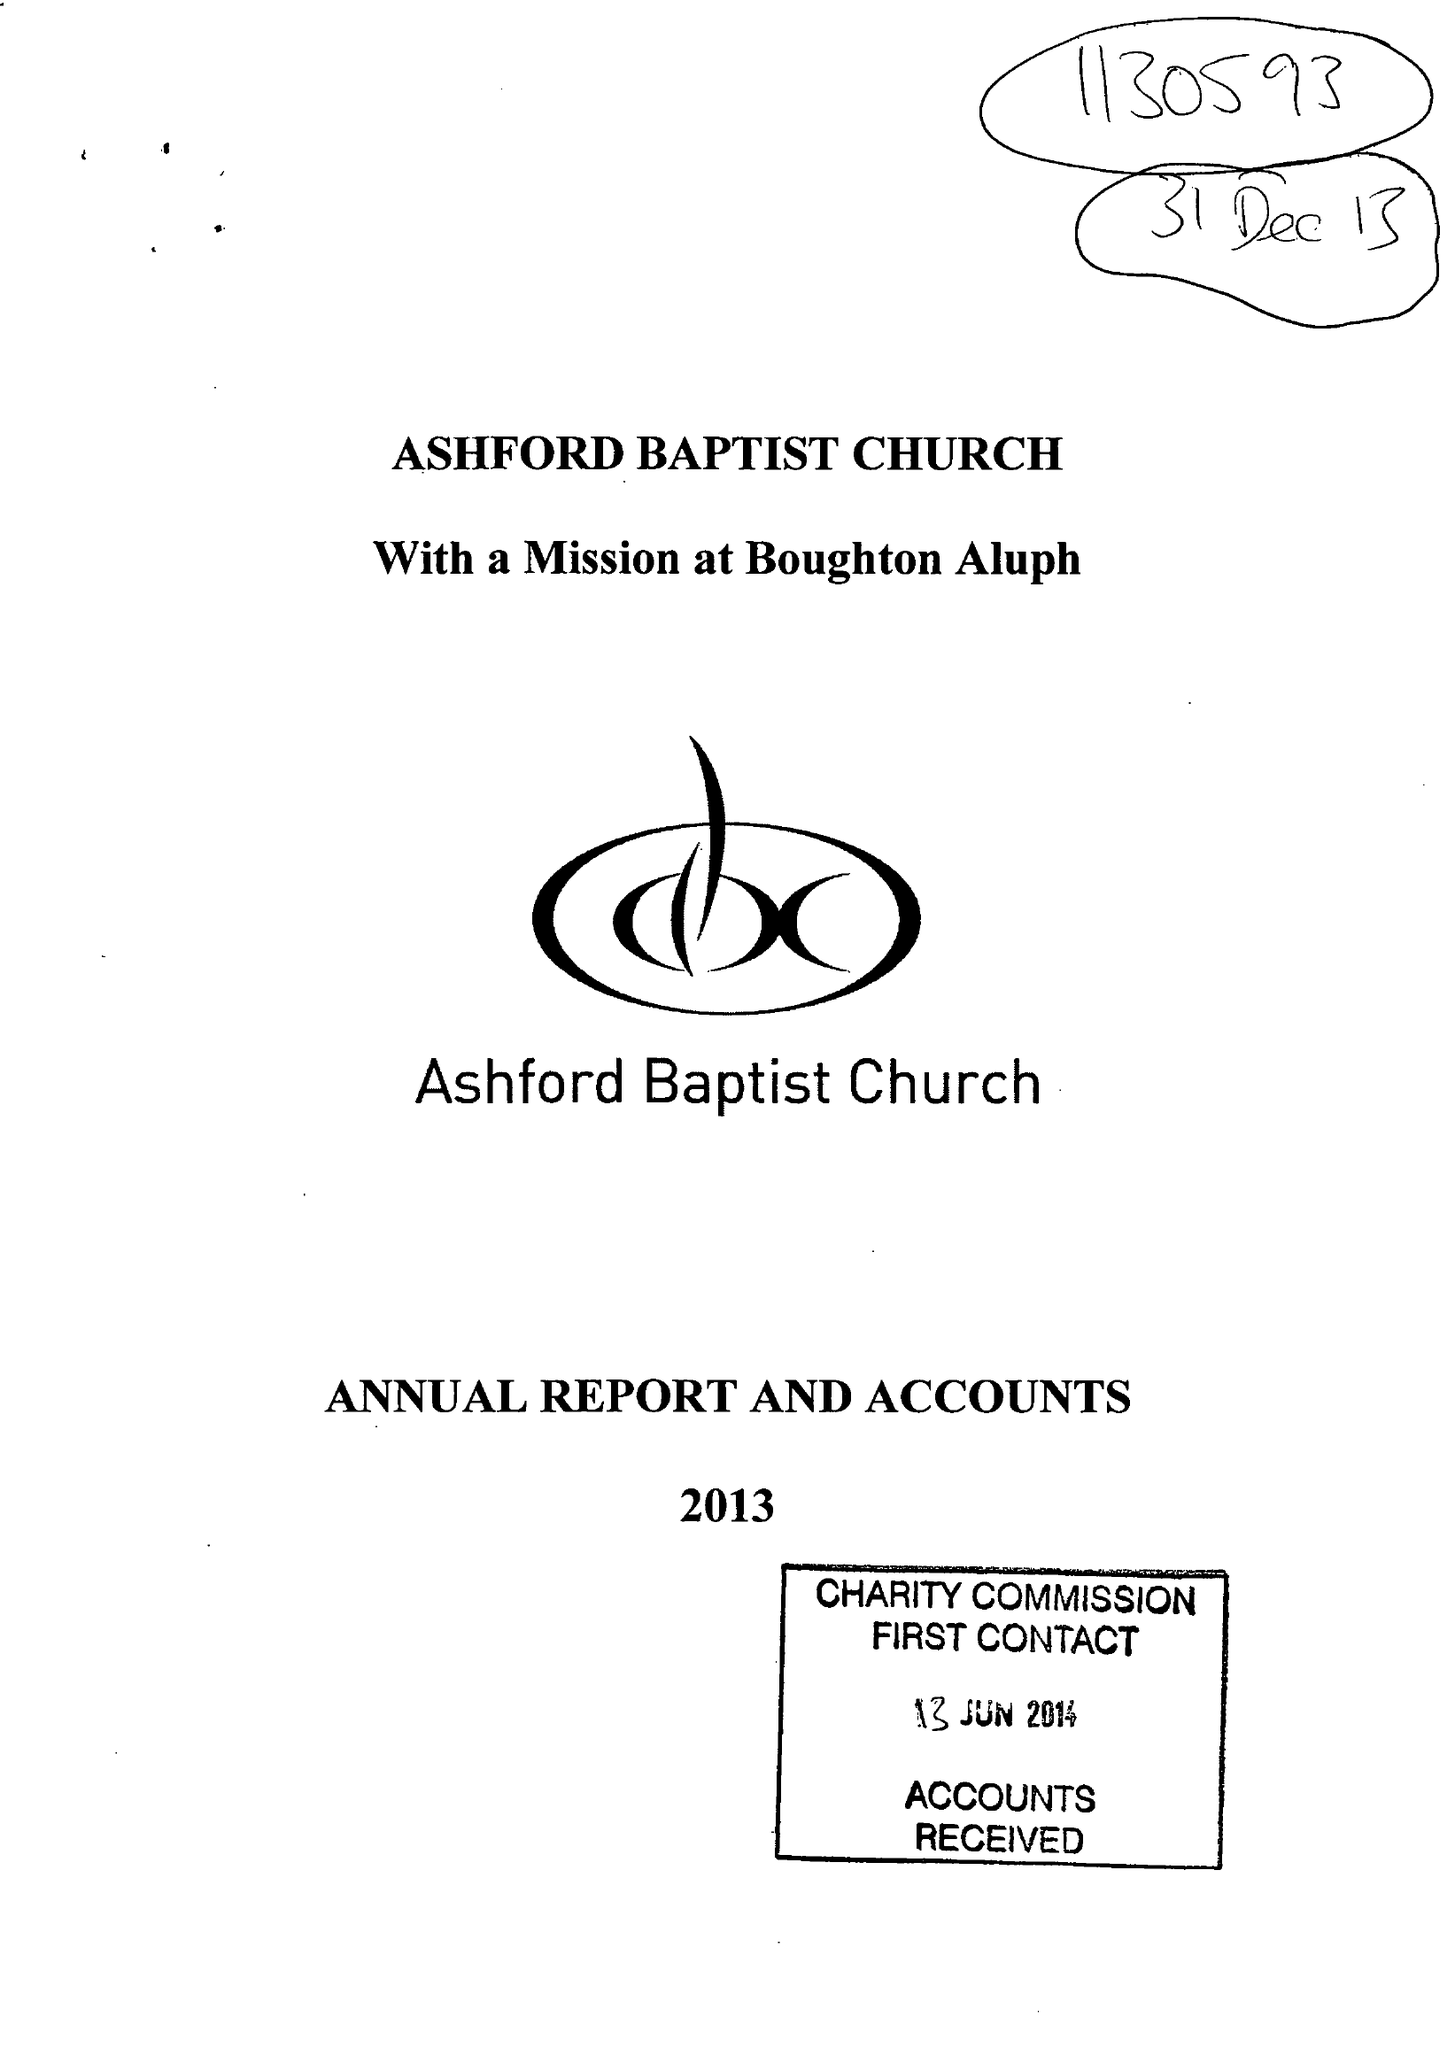What is the value for the income_annually_in_british_pounds?
Answer the question using a single word or phrase. 201243.00 